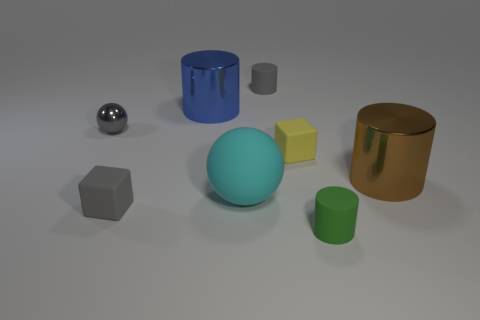What material is the tiny cylinder that is the same color as the tiny sphere?
Ensure brevity in your answer.  Rubber. What is the color of the small rubber cylinder that is behind the matte block on the right side of the large blue object?
Provide a short and direct response. Gray. Is there a shiny sphere of the same color as the tiny metallic object?
Offer a very short reply. No. The blue thing that is the same size as the cyan object is what shape?
Your answer should be very brief. Cylinder. There is a small rubber cube that is behind the big matte ball; how many gray rubber objects are in front of it?
Keep it short and to the point. 1. Is the color of the small sphere the same as the big sphere?
Offer a terse response. No. How many other things are there of the same material as the gray cylinder?
Provide a succinct answer. 4. There is a small thing that is in front of the rubber cube in front of the yellow rubber cube; what shape is it?
Offer a terse response. Cylinder. What is the size of the matte cylinder in front of the brown thing?
Give a very brief answer. Small. Are the brown thing and the small yellow object made of the same material?
Give a very brief answer. No. 